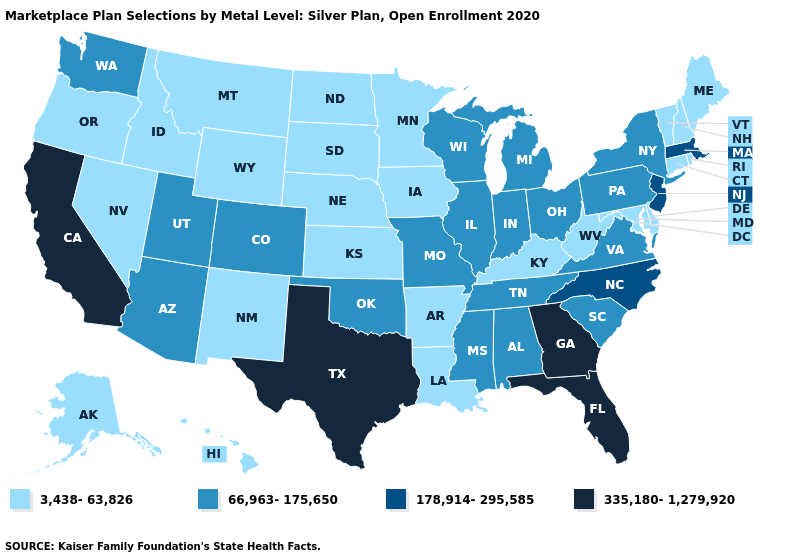Among the states that border Georgia , does North Carolina have the lowest value?
Short answer required. No. Which states have the lowest value in the West?
Quick response, please. Alaska, Hawaii, Idaho, Montana, Nevada, New Mexico, Oregon, Wyoming. What is the highest value in the Northeast ?
Quick response, please. 178,914-295,585. Does the map have missing data?
Give a very brief answer. No. What is the value of Virginia?
Write a very short answer. 66,963-175,650. Name the states that have a value in the range 3,438-63,826?
Keep it brief. Alaska, Arkansas, Connecticut, Delaware, Hawaii, Idaho, Iowa, Kansas, Kentucky, Louisiana, Maine, Maryland, Minnesota, Montana, Nebraska, Nevada, New Hampshire, New Mexico, North Dakota, Oregon, Rhode Island, South Dakota, Vermont, West Virginia, Wyoming. Does Florida have the lowest value in the USA?
Concise answer only. No. Does the first symbol in the legend represent the smallest category?
Write a very short answer. Yes. Name the states that have a value in the range 66,963-175,650?
Quick response, please. Alabama, Arizona, Colorado, Illinois, Indiana, Michigan, Mississippi, Missouri, New York, Ohio, Oklahoma, Pennsylvania, South Carolina, Tennessee, Utah, Virginia, Washington, Wisconsin. What is the value of Arkansas?
Short answer required. 3,438-63,826. Does Wyoming have the lowest value in the USA?
Quick response, please. Yes. Among the states that border Kentucky , does West Virginia have the highest value?
Write a very short answer. No. Name the states that have a value in the range 66,963-175,650?
Give a very brief answer. Alabama, Arizona, Colorado, Illinois, Indiana, Michigan, Mississippi, Missouri, New York, Ohio, Oklahoma, Pennsylvania, South Carolina, Tennessee, Utah, Virginia, Washington, Wisconsin. What is the value of Arkansas?
Write a very short answer. 3,438-63,826. What is the highest value in states that border Kentucky?
Short answer required. 66,963-175,650. 